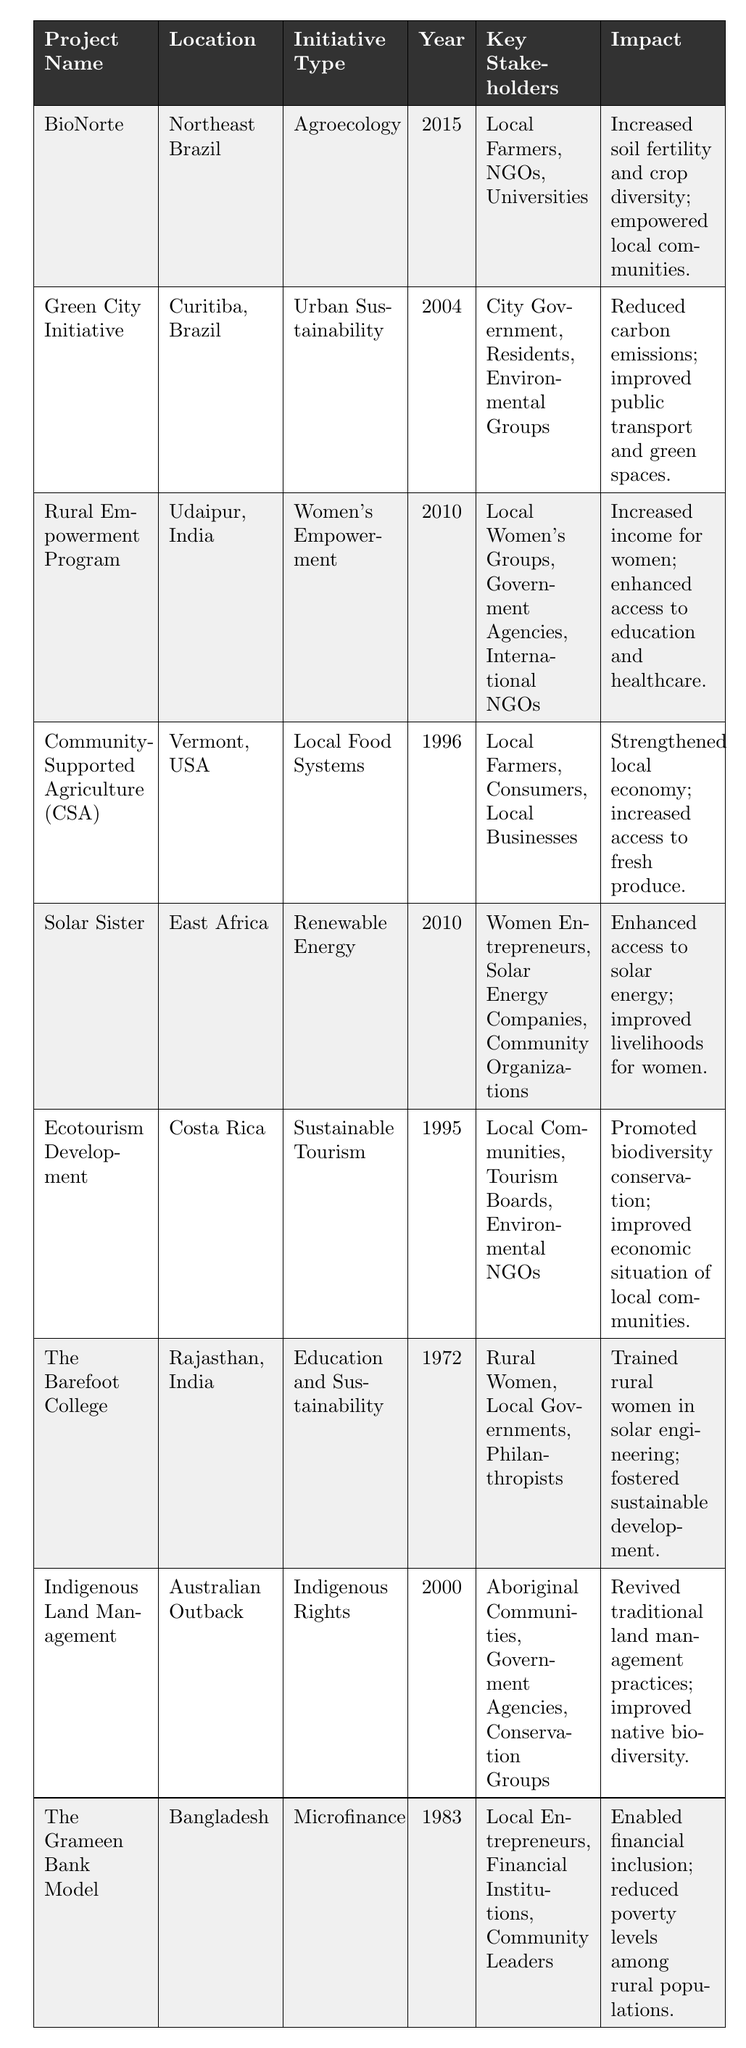What is the location of the "Solar Sister" project? The "Solar Sister" project is located in East Africa, as listed in the table.
Answer: East Africa Which initiative type is focused on women's empowerment? The "Rural Empowerment Program" is categorized under Women's Empowerment in the initiative type column.
Answer: Women's Empowerment How many projects in the table started in the year 2010? The "Rural Empowerment Program" and "Solar Sister" both started in 2010, which makes a total of two projects.
Answer: 2 What was the main impact of the "Community-Supported Agriculture (CSA)" project? The table states that the "Community-Supported Agriculture (CSA)" strengthened the local economy and increased access to fresh produce.
Answer: Strengthened local economy; increased access to fresh produce Is the "Green City Initiative" an urban sustainability project? Yes, according to the initiative type listed in the table, "Green City Initiative" falls under Urban Sustainability.
Answer: Yes Which project has the longest history, starting in 1972? The "Barefoot College" started in 1972, making it the project with the longest history in the table.
Answer: The Barefoot College Compare the impacts of "BioNorte" and "Indigenous Land Management." "BioNorte" increased soil fertility and crop diversity while empowering local communities; "Indigenous Land Management" revived traditional land management practices and improved biodiversity. Both projects emphasize local empowerment but in different contexts.
Answer: Different focuses on empowerment and biodiversity What is the common goal of the projects "Solar Sister" and "Rural Empowerment Program"? Both projects aim to improve livelihoods, specifically for women; "Solar Sister" focuses on renewable energy access while "Rural Empowerment Program" enhances income and education for women.
Answer: Improving livelihoods for women What unique key stakeholders are involved in the "The Grameen Bank Model"? The key stakeholders mentioned for "The Grameen Bank Model" include local entrepreneurs, financial institutions, and community leaders, focusing on financial inclusion aspects.
Answer: Local entrepreneurs, financial institutions, and community leaders Which project benefits local communities through ecotourism, and what is one of its impacts? The "Ecotourism Development" project benefits local communities, promoting biodiversity conservation as one of its impacts.
Answer: Ecotourism Development; promotes biodiversity conservation 